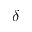Convert formula to latex. <formula><loc_0><loc_0><loc_500><loc_500>\delta</formula> 